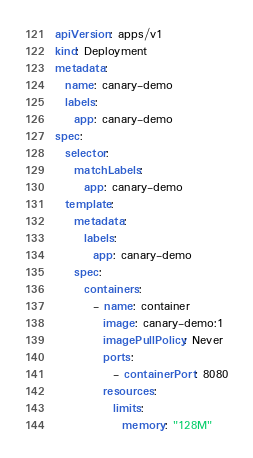<code> <loc_0><loc_0><loc_500><loc_500><_YAML_>apiVersion: apps/v1
kind: Deployment
metadata:
  name: canary-demo
  labels:
    app: canary-demo
spec:
  selector:
    matchLabels:
      app: canary-demo
  template:
    metadata:
      labels:
        app: canary-demo
    spec:
      containers:
        - name: container
          image: canary-demo:1
          imagePullPolicy: Never
          ports:
            - containerPort: 8080
          resources:
            limits:
              memory: "128M"
</code> 